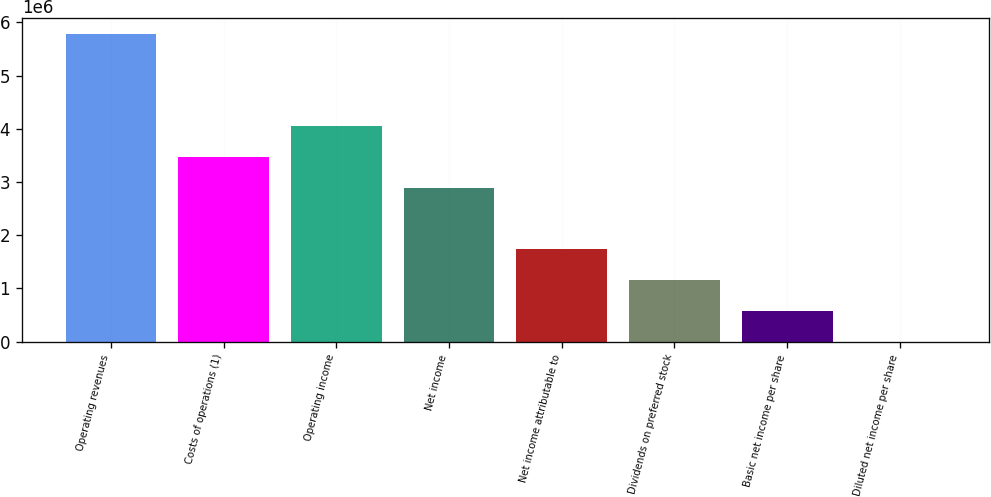Convert chart. <chart><loc_0><loc_0><loc_500><loc_500><bar_chart><fcel>Operating revenues<fcel>Costs of operations (1)<fcel>Operating income<fcel>Net income<fcel>Net income attributable to<fcel>Dividends on preferred stock<fcel>Basic net income per share<fcel>Diluted net income per share<nl><fcel>5.78567e+06<fcel>3.4714e+06<fcel>4.04997e+06<fcel>2.89283e+06<fcel>1.7357e+06<fcel>1.15714e+06<fcel>578569<fcel>1.98<nl></chart> 